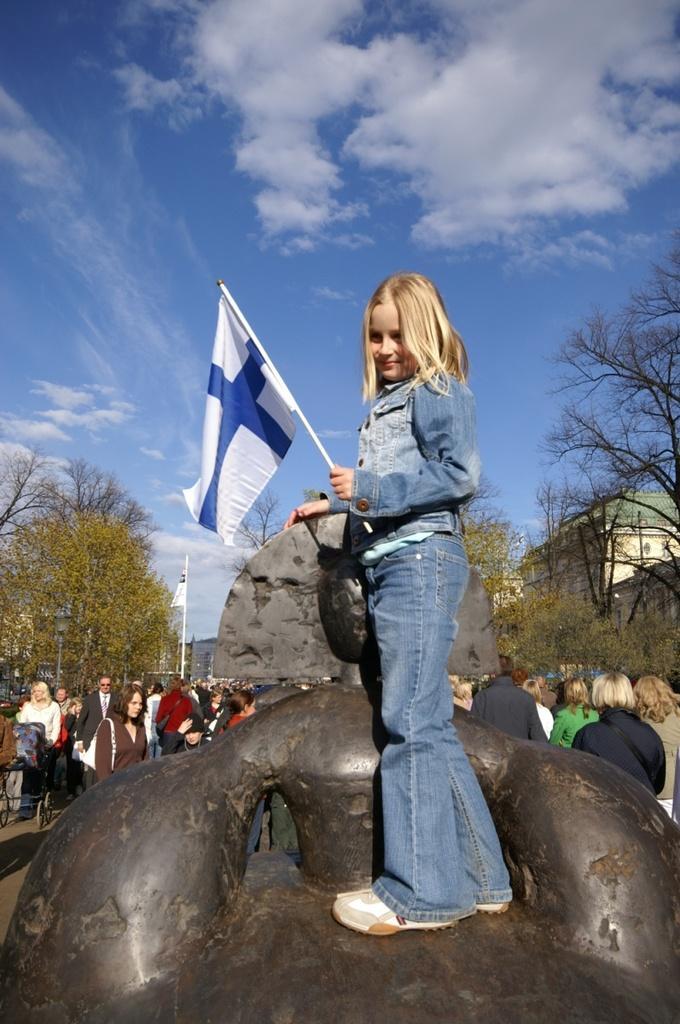In one or two sentences, can you explain what this image depicts? In this image I can see a girl is holding a flag in the hand. In the background I can see people, trees and the sky. Here I can see building and a flag. 